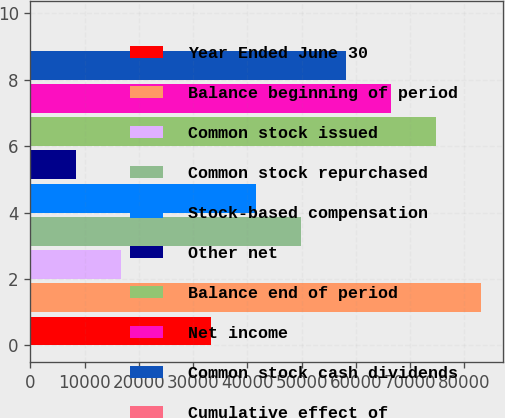Convert chart to OTSL. <chart><loc_0><loc_0><loc_500><loc_500><bar_chart><fcel>Year Ended June 30<fcel>Balance beginning of period<fcel>Common stock issued<fcel>Common stock repurchased<fcel>Stock-based compensation<fcel>Other net<fcel>Balance end of period<fcel>Net income<fcel>Common stock cash dividends<fcel>Cumulative effect of<nl><fcel>33237.4<fcel>83090<fcel>16619.8<fcel>49854.9<fcel>41546.1<fcel>8311.05<fcel>74781.2<fcel>66472.4<fcel>58163.7<fcel>2.28<nl></chart> 